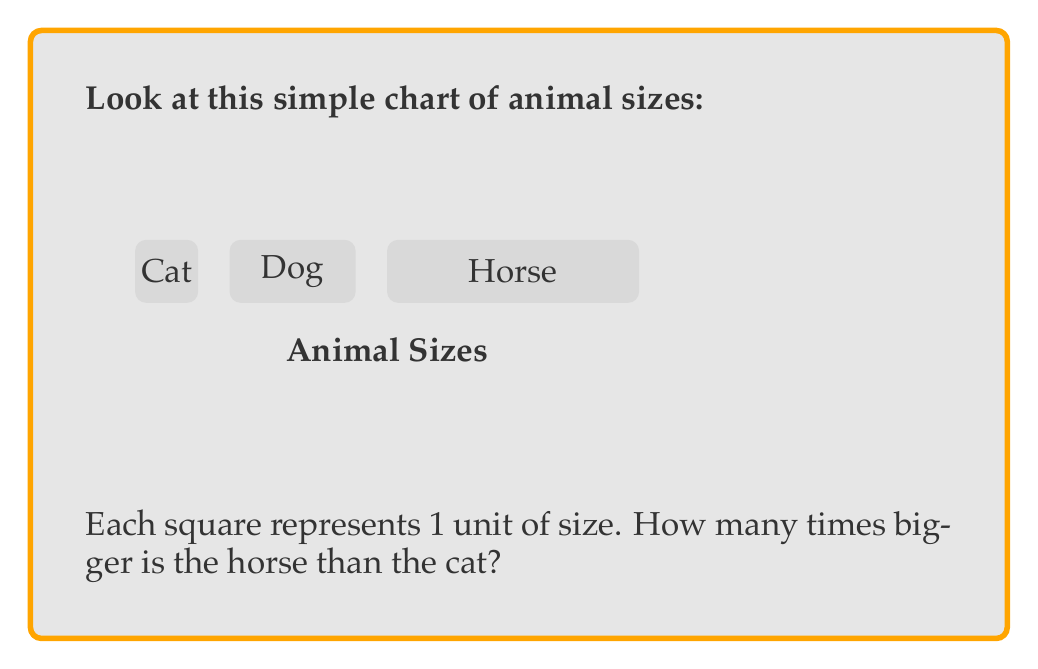Could you help me with this problem? Let's look at this step-by-step:

1. First, we need to count how many squares each animal has:
   - The cat has 1 square
   - The dog has 2 squares
   - The horse has 4 squares

2. We want to know how many times bigger the horse is compared to the cat.

3. To find this, we divide the horse's size by the cat's size:
   $\frac{\text{Horse size}}{\text{Cat size}} = \frac{4}{1} = 4$

4. This means the horse is 4 times bigger than the cat.

Remember, when we compare sizes, we're looking at how many times one thing fits into another. The horse's 4 squares can fit the cat's 1 square 4 times!
Answer: The horse is 4 times bigger than the cat. 